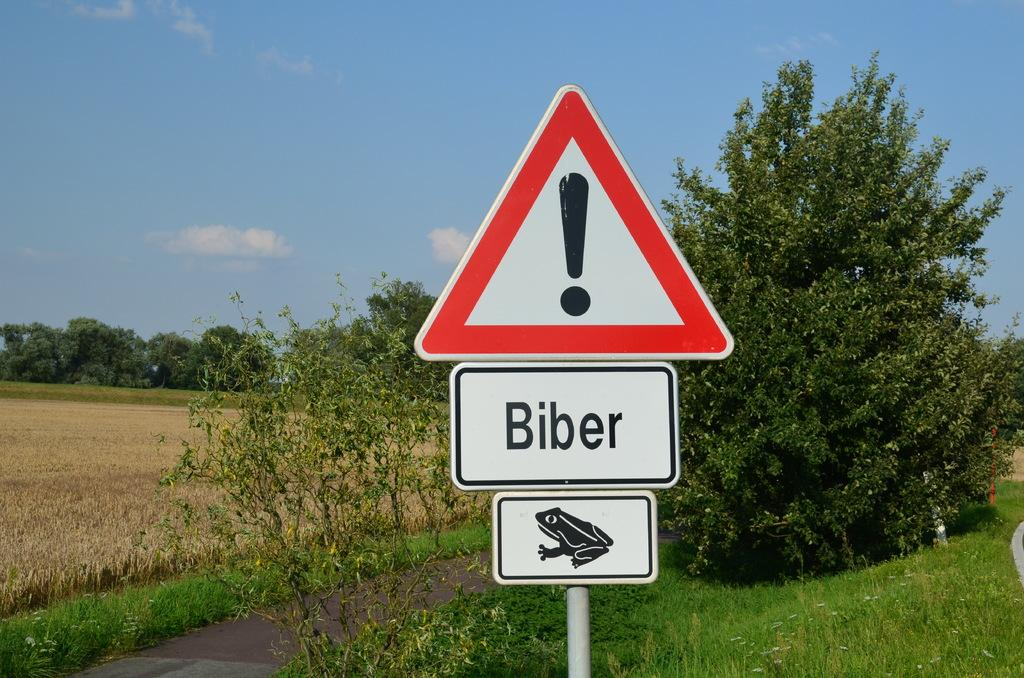<image>
Give a short and clear explanation of the subsequent image. A red caution sign with a pic of a frog on it that says Biber. 